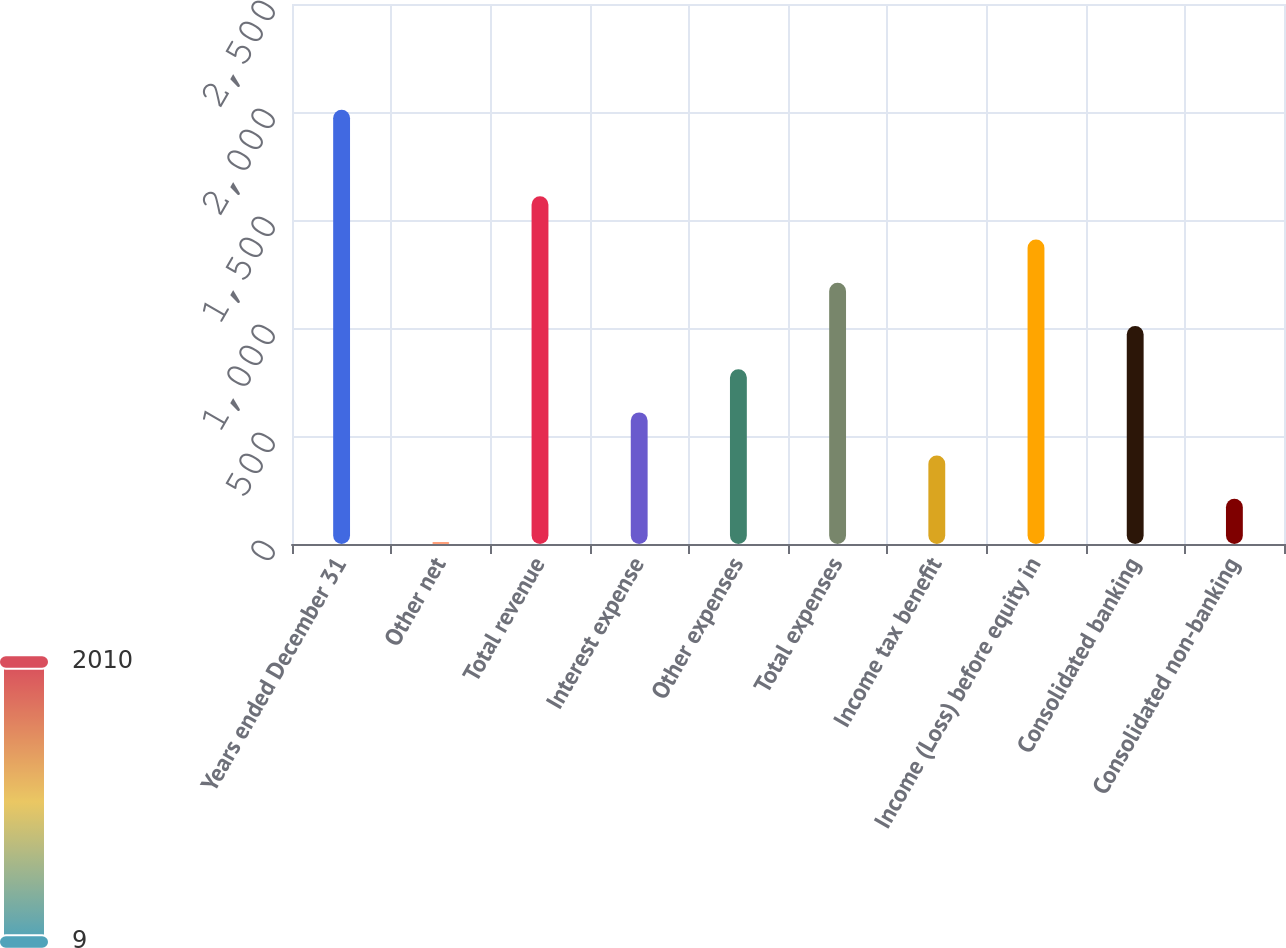Convert chart to OTSL. <chart><loc_0><loc_0><loc_500><loc_500><bar_chart><fcel>Years ended December 31<fcel>Other net<fcel>Total revenue<fcel>Interest expense<fcel>Other expenses<fcel>Total expenses<fcel>Income tax benefit<fcel>Income (Loss) before equity in<fcel>Consolidated banking<fcel>Consolidated non-banking<nl><fcel>2010<fcel>9<fcel>1609.8<fcel>609.3<fcel>809.4<fcel>1209.6<fcel>409.2<fcel>1409.7<fcel>1009.5<fcel>209.1<nl></chart> 